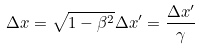<formula> <loc_0><loc_0><loc_500><loc_500>\Delta x = \sqrt { 1 - \beta ^ { 2 } } \Delta x ^ { \prime } = \frac { \Delta x ^ { \prime } } { \gamma }</formula> 